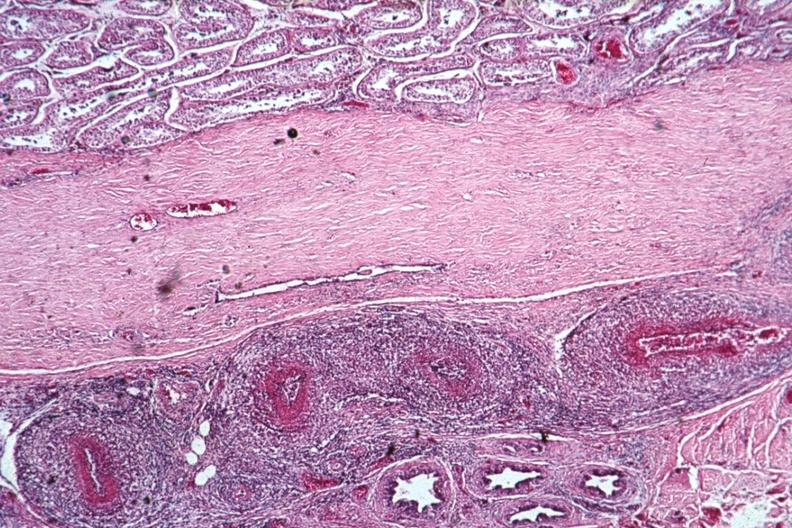does this image show well shown vasculitis lesion of pan type?
Answer the question using a single word or phrase. Yes 